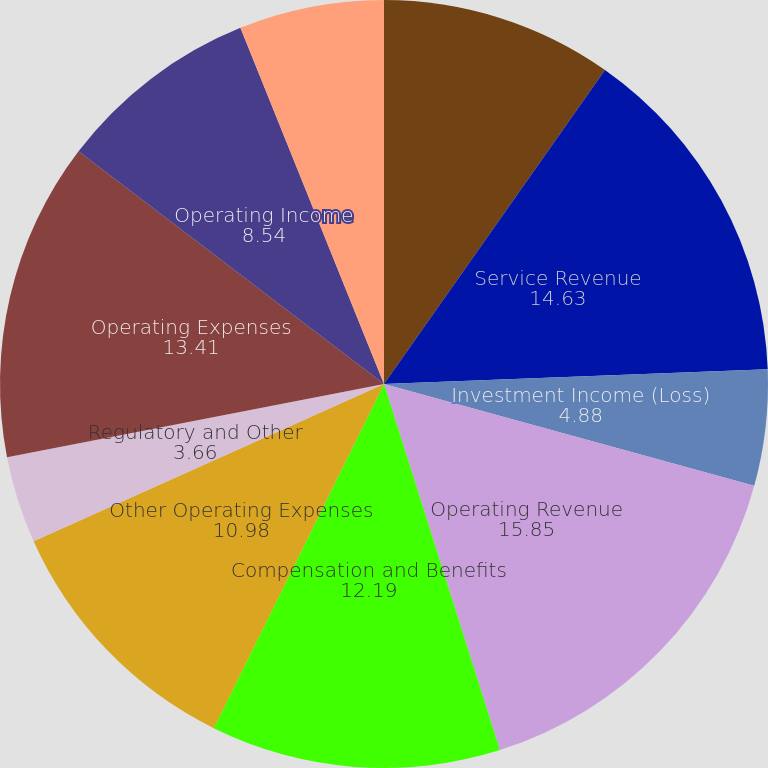Convert chart to OTSL. <chart><loc_0><loc_0><loc_500><loc_500><pie_chart><fcel>(In millions except per share<fcel>Service Revenue<fcel>Investment Income (Loss)<fcel>Operating Revenue<fcel>Compensation and Benefits<fcel>Other Operating Expenses<fcel>Regulatory and Other<fcel>Operating Expenses<fcel>Operating Income<fcel>Income from Continuing<nl><fcel>9.76%<fcel>14.63%<fcel>4.88%<fcel>15.85%<fcel>12.19%<fcel>10.98%<fcel>3.66%<fcel>13.41%<fcel>8.54%<fcel>6.1%<nl></chart> 